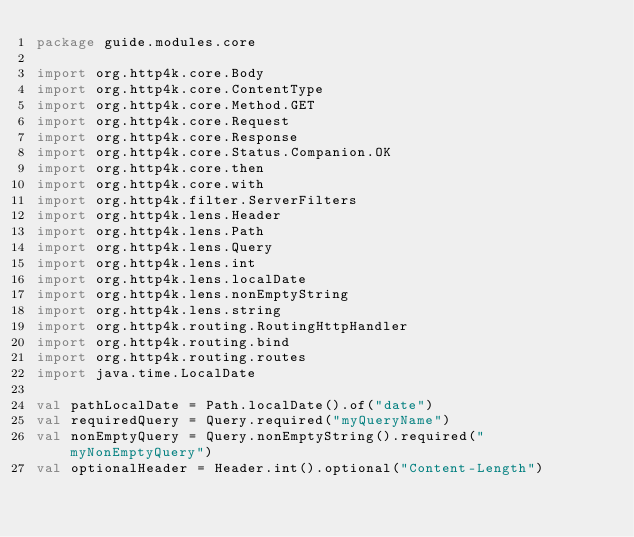Convert code to text. <code><loc_0><loc_0><loc_500><loc_500><_Kotlin_>package guide.modules.core

import org.http4k.core.Body
import org.http4k.core.ContentType
import org.http4k.core.Method.GET
import org.http4k.core.Request
import org.http4k.core.Response
import org.http4k.core.Status.Companion.OK
import org.http4k.core.then
import org.http4k.core.with
import org.http4k.filter.ServerFilters
import org.http4k.lens.Header
import org.http4k.lens.Path
import org.http4k.lens.Query
import org.http4k.lens.int
import org.http4k.lens.localDate
import org.http4k.lens.nonEmptyString
import org.http4k.lens.string
import org.http4k.routing.RoutingHttpHandler
import org.http4k.routing.bind
import org.http4k.routing.routes
import java.time.LocalDate

val pathLocalDate = Path.localDate().of("date")
val requiredQuery = Query.required("myQueryName")
val nonEmptyQuery = Query.nonEmptyString().required("myNonEmptyQuery")
val optionalHeader = Header.int().optional("Content-Length")</code> 